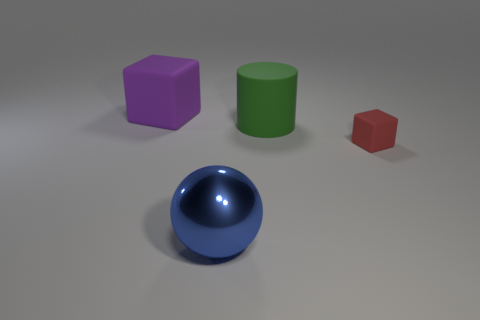Add 1 big metallic objects. How many objects exist? 5 Subtract all red blocks. How many blocks are left? 1 Add 1 large objects. How many large objects are left? 4 Add 1 large shiny spheres. How many large shiny spheres exist? 2 Subtract 0 cyan spheres. How many objects are left? 4 Subtract all cyan spheres. Subtract all gray blocks. How many spheres are left? 1 Subtract all red balls. How many purple blocks are left? 1 Subtract all green objects. Subtract all green objects. How many objects are left? 2 